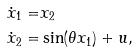Convert formula to latex. <formula><loc_0><loc_0><loc_500><loc_500>\dot { x } _ { 1 } = & x _ { 2 } \\ \dot { x } _ { 2 } = & \sin ( \theta x _ { 1 } ) + u ,</formula> 